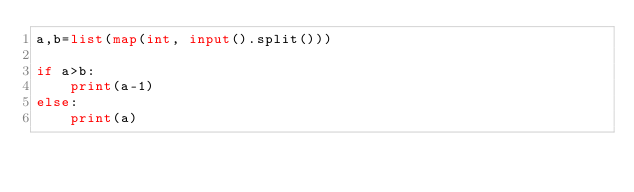Convert code to text. <code><loc_0><loc_0><loc_500><loc_500><_Python_>a,b=list(map(int, input().split()))

if a>b:
    print(a-1)
else:
    print(a)</code> 